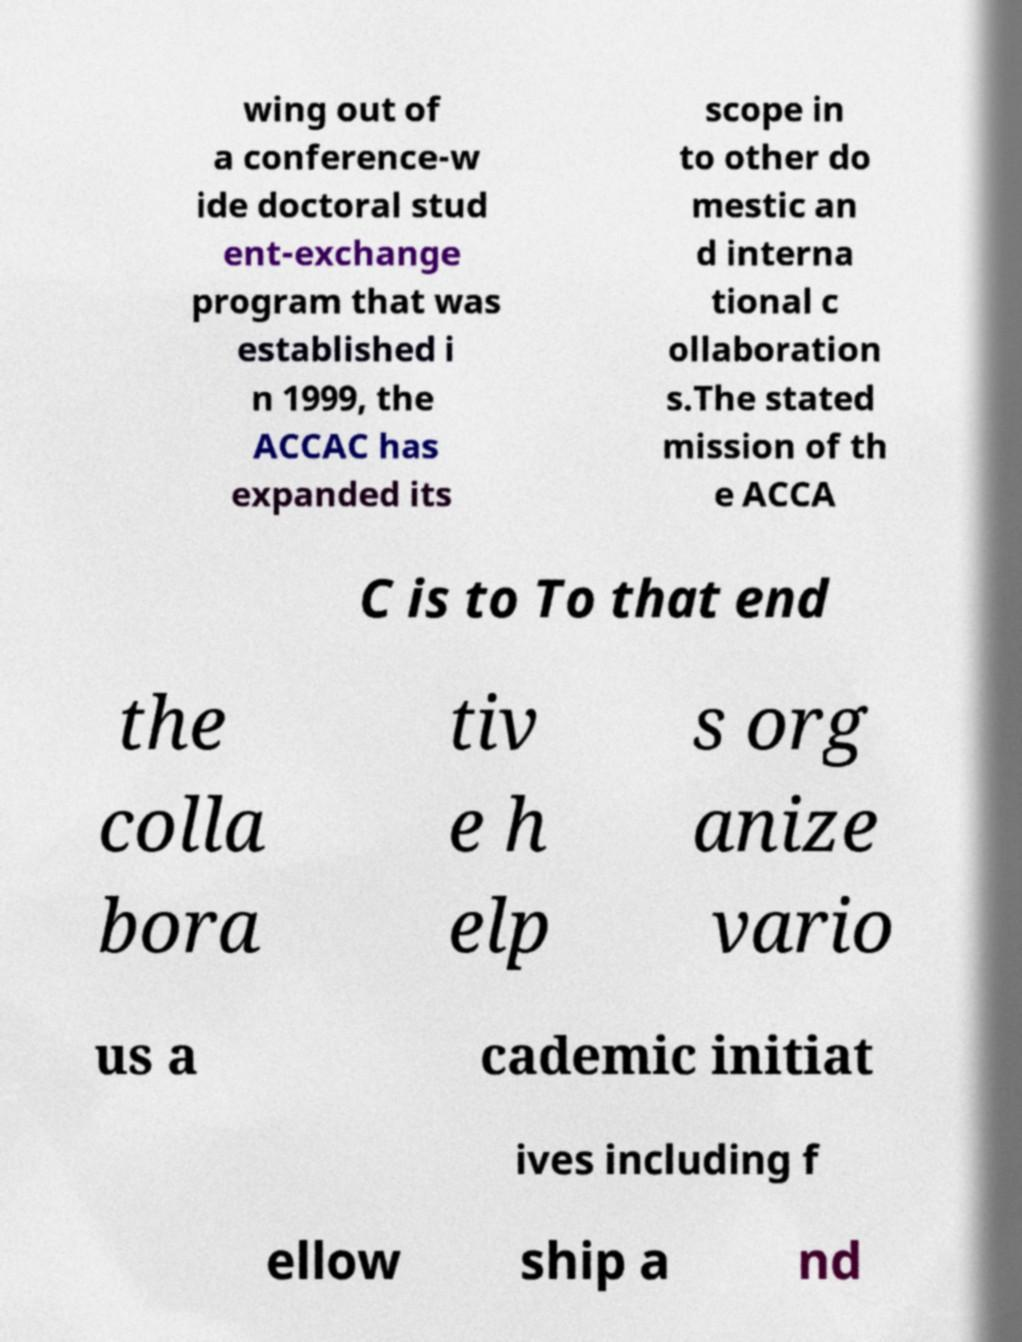Please identify and transcribe the text found in this image. wing out of a conference-w ide doctoral stud ent-exchange program that was established i n 1999, the ACCAC has expanded its scope in to other do mestic an d interna tional c ollaboration s.The stated mission of th e ACCA C is to To that end the colla bora tiv e h elp s org anize vario us a cademic initiat ives including f ellow ship a nd 